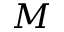Convert formula to latex. <formula><loc_0><loc_0><loc_500><loc_500>M</formula> 